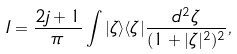Convert formula to latex. <formula><loc_0><loc_0><loc_500><loc_500>I = \frac { 2 j + 1 } { \pi } \int | \zeta \rangle \langle \zeta | \frac { d ^ { 2 } \zeta } { ( 1 + | \zeta | ^ { 2 } ) ^ { 2 } } ,</formula> 